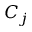Convert formula to latex. <formula><loc_0><loc_0><loc_500><loc_500>C _ { j }</formula> 